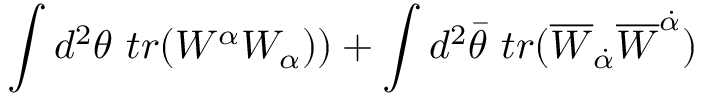<formula> <loc_0><loc_0><loc_500><loc_500>\int d ^ { 2 } \theta t r ( W ^ { \alpha } W _ { \alpha } ) ) + \int d ^ { 2 } \bar { \theta } t r ( \overline { W } _ { \dot { \alpha } } \overline { W } ^ { \dot { \alpha } } )</formula> 